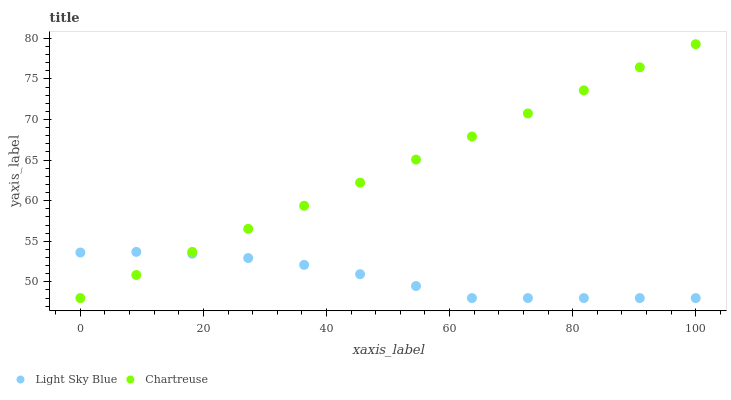Does Light Sky Blue have the minimum area under the curve?
Answer yes or no. Yes. Does Chartreuse have the maximum area under the curve?
Answer yes or no. Yes. Does Light Sky Blue have the maximum area under the curve?
Answer yes or no. No. Is Chartreuse the smoothest?
Answer yes or no. Yes. Is Light Sky Blue the roughest?
Answer yes or no. Yes. Is Light Sky Blue the smoothest?
Answer yes or no. No. Does Chartreuse have the lowest value?
Answer yes or no. Yes. Does Chartreuse have the highest value?
Answer yes or no. Yes. Does Light Sky Blue have the highest value?
Answer yes or no. No. Does Light Sky Blue intersect Chartreuse?
Answer yes or no. Yes. Is Light Sky Blue less than Chartreuse?
Answer yes or no. No. Is Light Sky Blue greater than Chartreuse?
Answer yes or no. No. 